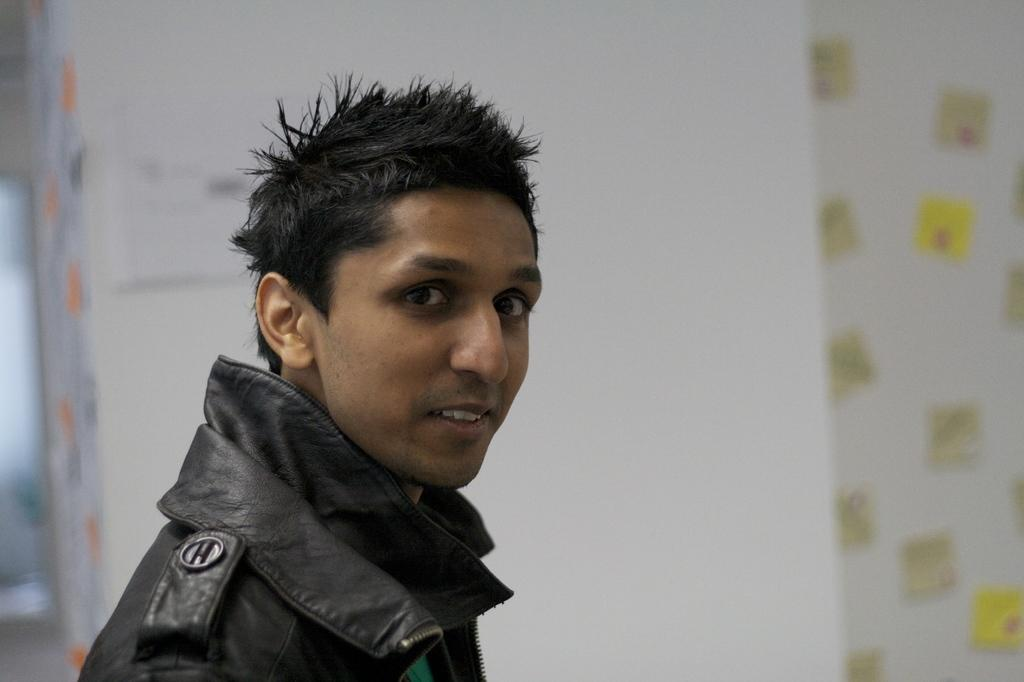Who or what is in the image? There is a person in the image. What is the person wearing? The person is wearing a black color jacket. Where is the person located in the image? The person is on the left side of the image. What can be seen in the background of the image? There is a white color wall in the background of the image. What type of amusement can be seen in the image? There is no amusement present in the image; it features a person wearing a black color jacket and standing on the left side of the image with a white color wall in the background. Can you tell me how many trains are visible in the image? There are no trains present in the image. 